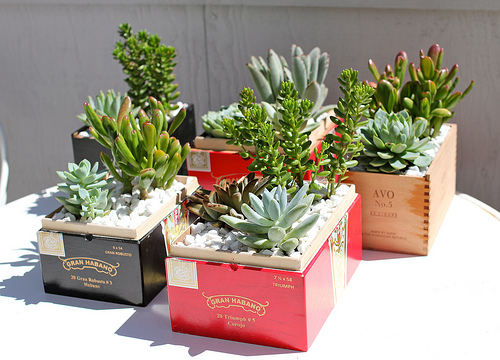<image>
Is there a cactus in the box? Yes. The cactus is contained within or inside the box, showing a containment relationship. Where is the succulent in relation to the cigar box? Is it in the cigar box? Yes. The succulent is contained within or inside the cigar box, showing a containment relationship. 